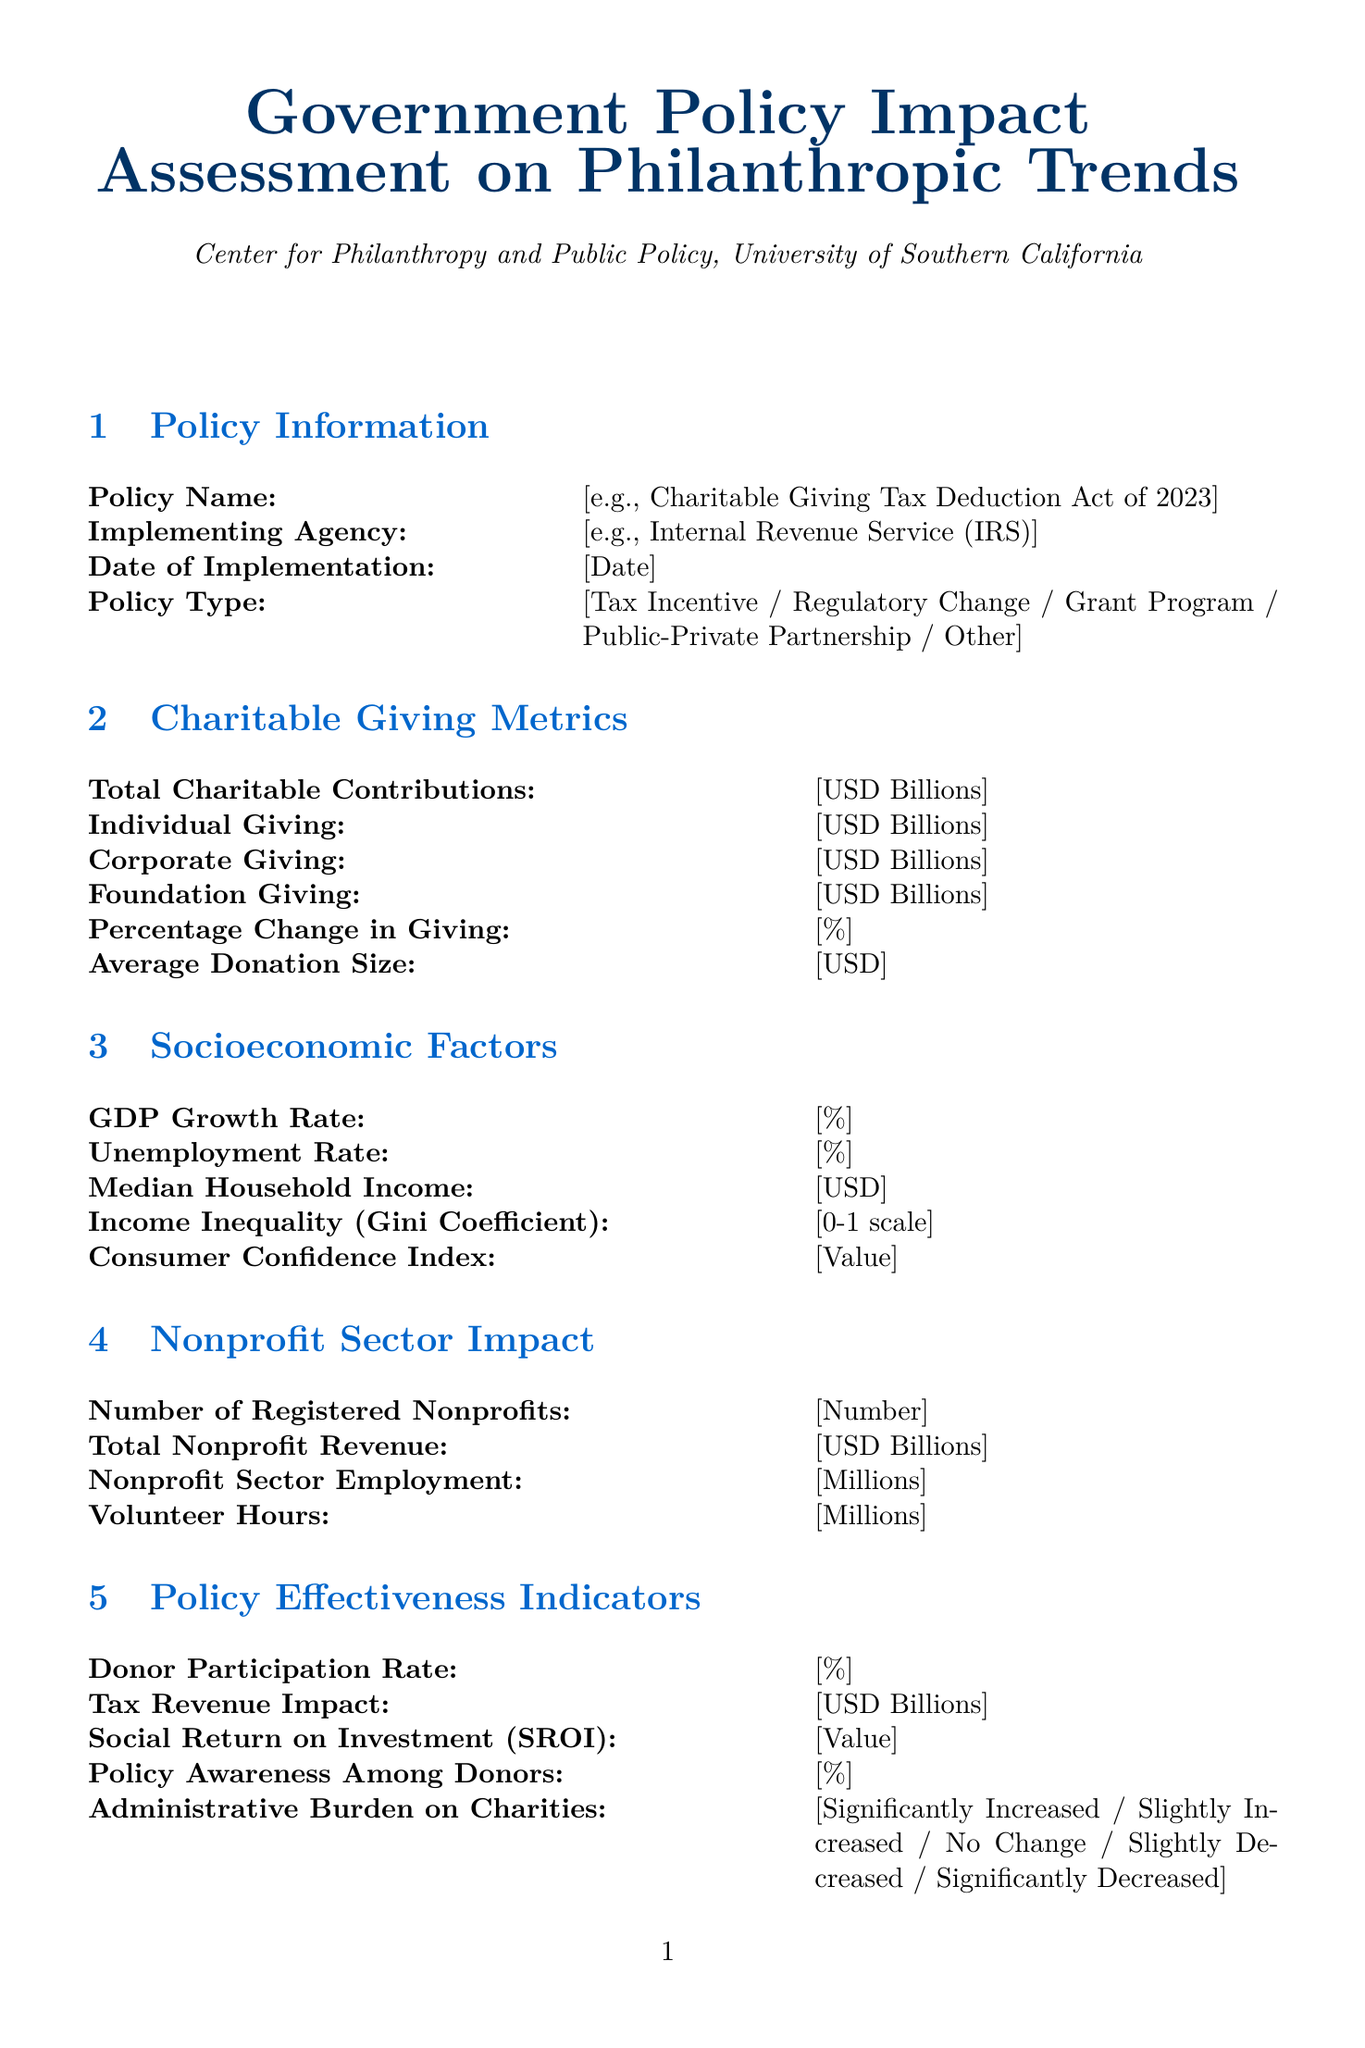What is the name of the policy? This is the field that asks for the name of the government policy being assessed, such as "Charitable Giving Tax Deduction Act of 2023".
Answer: Charitable Giving Tax Deduction Act of 2023 Who is the implementing agency? This field requests the name of the agency responsible for implementing the policy, for example, the IRS.
Answer: Internal Revenue Service (IRS) What is the date of implementation? This is a field designated for the date on which the policy came into effect.
Answer: [Date] What type of policy is being assessed? The policy type can be selected from several options including tax incentive or grant program.
Answer: Tax Incentive What was the percentage change in giving? This measures the variation in charitable contributions before and after the policy implementation.
Answer: [%] How many registered nonprofits are there? This field indicates the number of nonprofits that are officially registered within the region or country studied.
Answer: [Number] What is the unemployment rate? This field captures the current unemployment rate, which is a critical socioeconomic factor.
Answer: [%] What is the donor participation rate? This indicator displays the percentage of potential donors that actively participate in charitable giving under the policy.
Answer: [%] Was there an administrative burden on charities? This field notes the perceived changes in administrative tasks or requirements for charities due to the policy.
Answer: [Significantly Increased / Slightly Increased / No Change / Slightly Decreased / Significantly Decreased] 